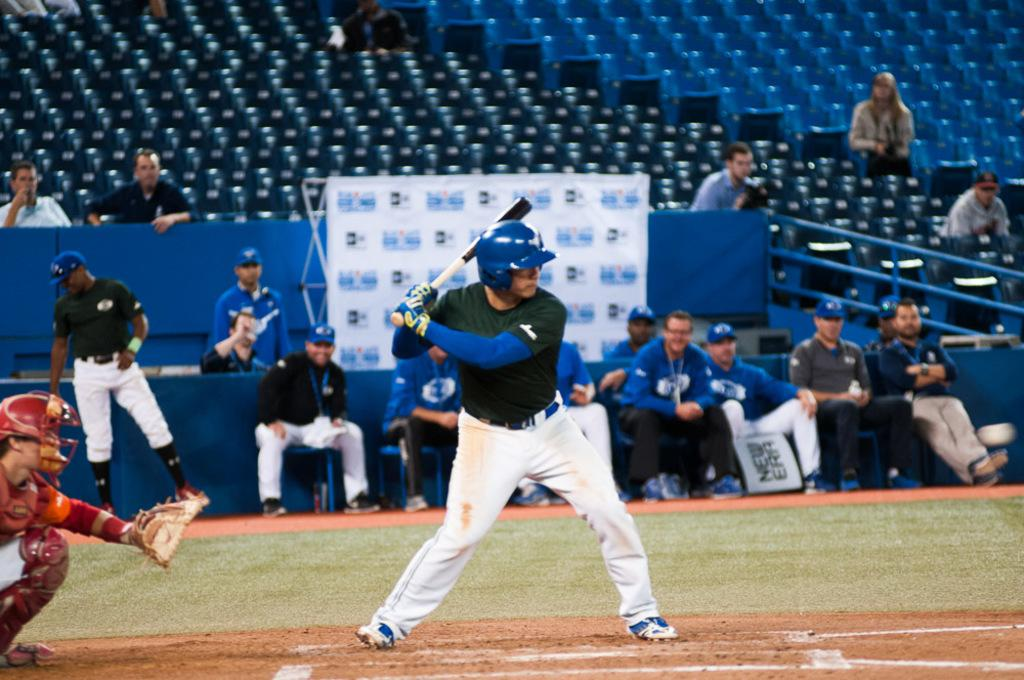What is the person in the image doing? The person is standing on the ground and holding a bat. Can you describe the people in the background of the image? There are people visible in the background of the image, but their specific actions or characteristics are not mentioned in the provided facts. What might the person holding the bat be about to do? The person holding the bat might be about to play a sport or engage in an activity that involves using a bat. What is the condition of the lock on the door in the image? There is no mention of a door or lock in the provided facts, so we cannot answer this question based on the image. 